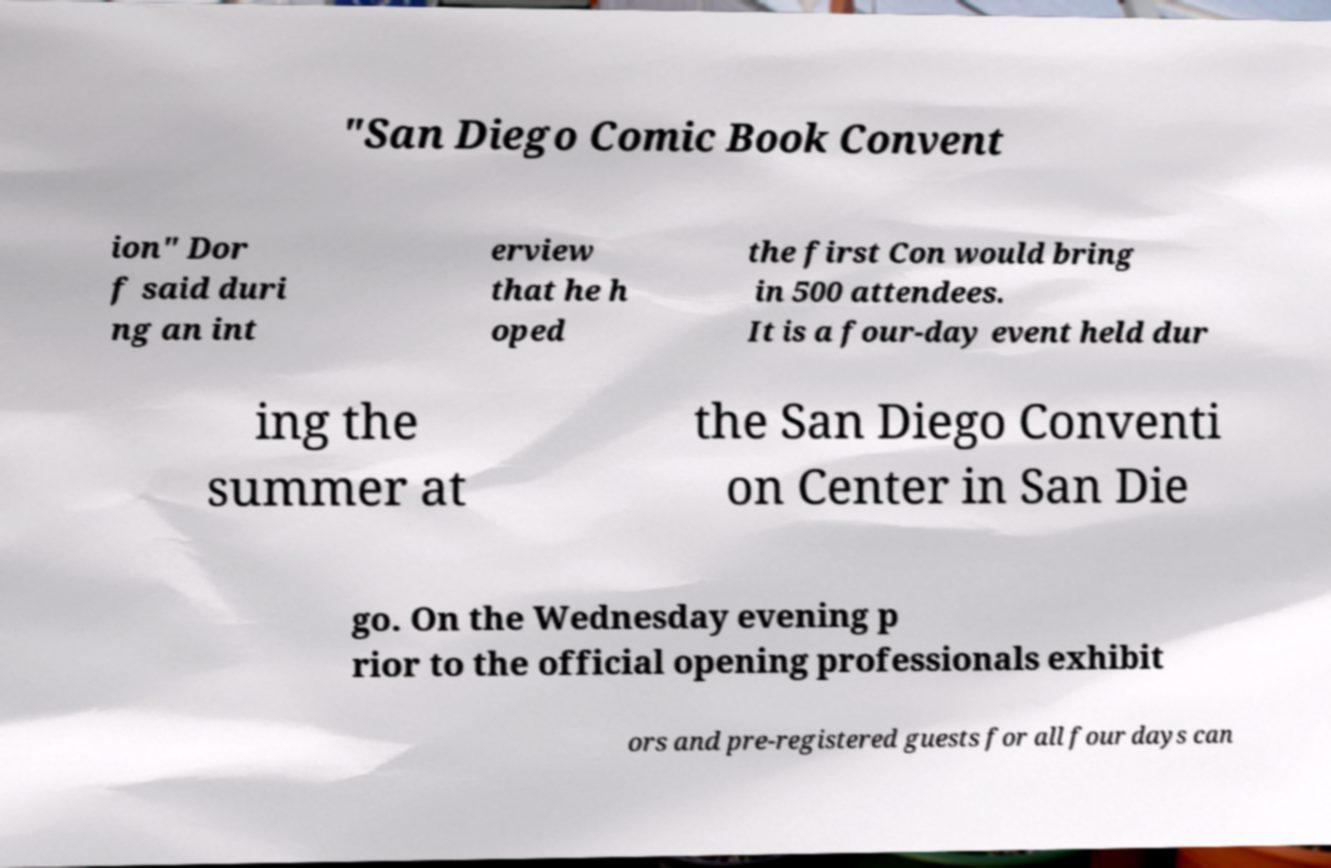I need the written content from this picture converted into text. Can you do that? "San Diego Comic Book Convent ion" Dor f said duri ng an int erview that he h oped the first Con would bring in 500 attendees. It is a four-day event held dur ing the summer at the San Diego Conventi on Center in San Die go. On the Wednesday evening p rior to the official opening professionals exhibit ors and pre-registered guests for all four days can 